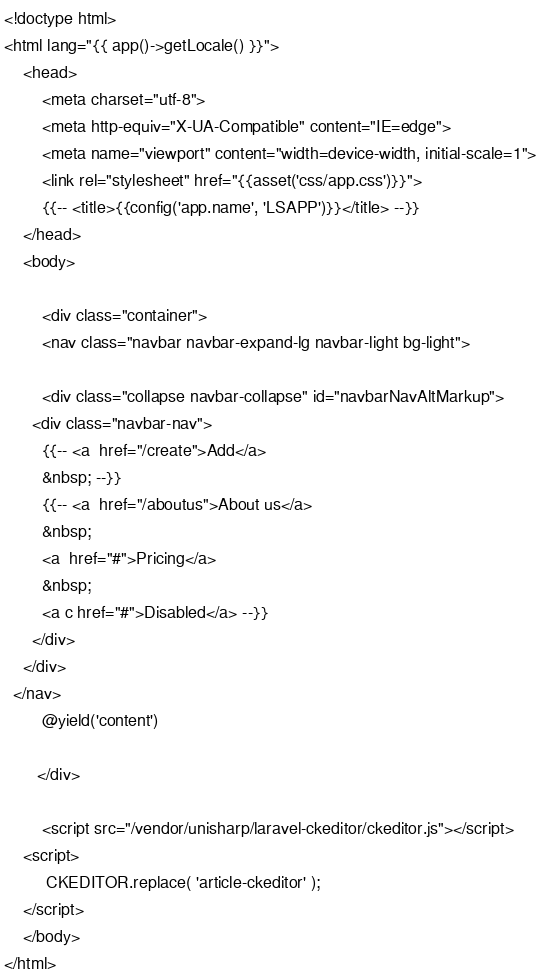Convert code to text. <code><loc_0><loc_0><loc_500><loc_500><_PHP_><!doctype html>
<html lang="{{ app()->getLocale() }}">
    <head>
        <meta charset="utf-8">
        <meta http-equiv="X-UA-Compatible" content="IE=edge">
        <meta name="viewport" content="width=device-width, initial-scale=1">
        <link rel="stylesheet" href="{{asset('css/app.css')}}">
        {{-- <title>{{config('app.name', 'LSAPP')}}</title> --}}
    </head>
    <body>
       
        <div class="container">
        <nav class="navbar navbar-expand-lg navbar-light bg-light">
  
        <div class="collapse navbar-collapse" id="navbarNavAltMarkup">
      <div class="navbar-nav">
        {{-- <a  href="/create">Add</a>
        &nbsp; --}}
        {{-- <a  href="/aboutus">About us</a>
        &nbsp;
        <a  href="#">Pricing</a>
        &nbsp;
        <a c href="#">Disabled</a> --}}
      </div>
    </div>
  </nav>
        @yield('content')
       
       </div>

        <script src="/vendor/unisharp/laravel-ckeditor/ckeditor.js"></script> 
    <script>
         CKEDITOR.replace( 'article-ckeditor' );
    </script>
    </body>
</html></code> 